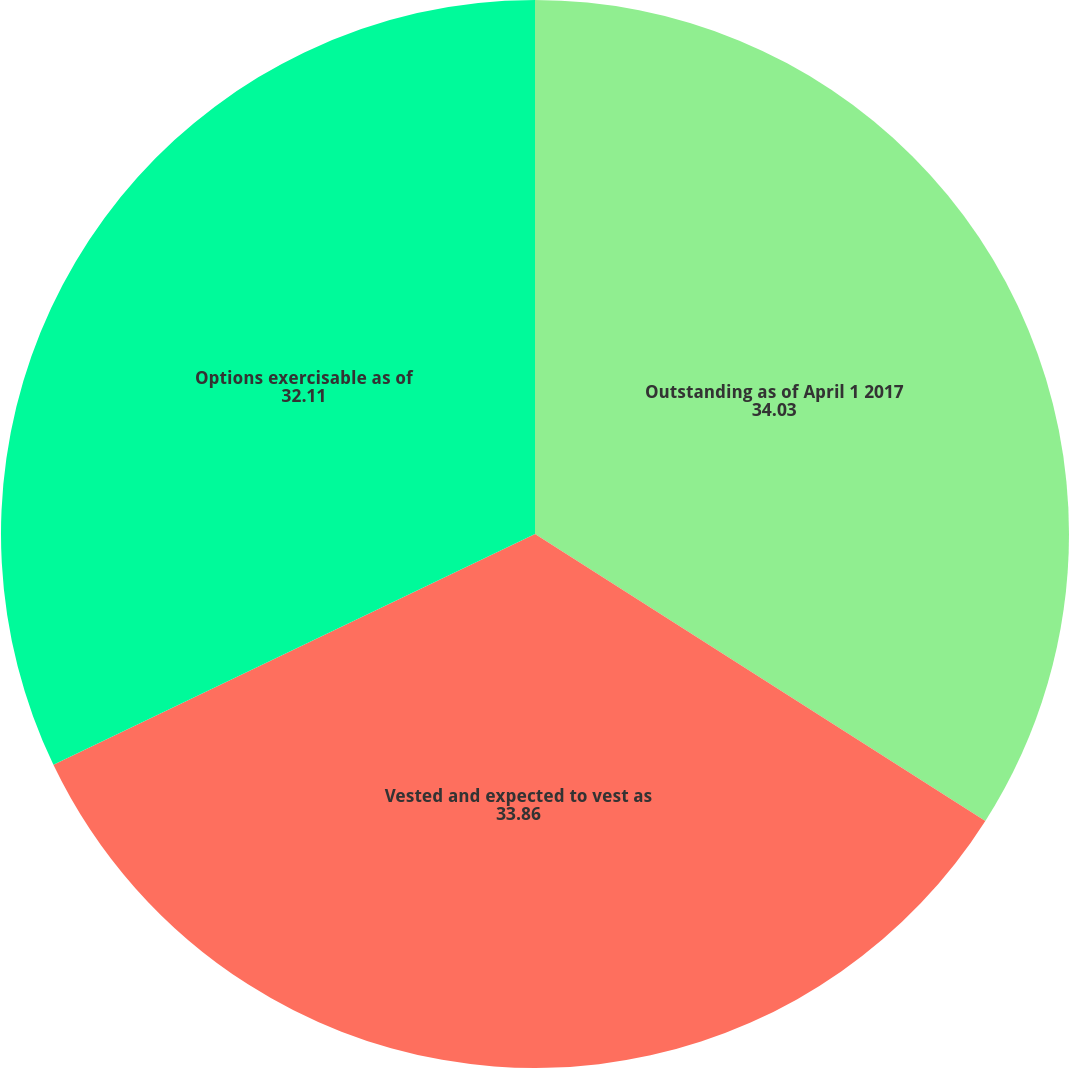<chart> <loc_0><loc_0><loc_500><loc_500><pie_chart><fcel>Outstanding as of April 1 2017<fcel>Vested and expected to vest as<fcel>Options exercisable as of<nl><fcel>34.03%<fcel>33.86%<fcel>32.11%<nl></chart> 